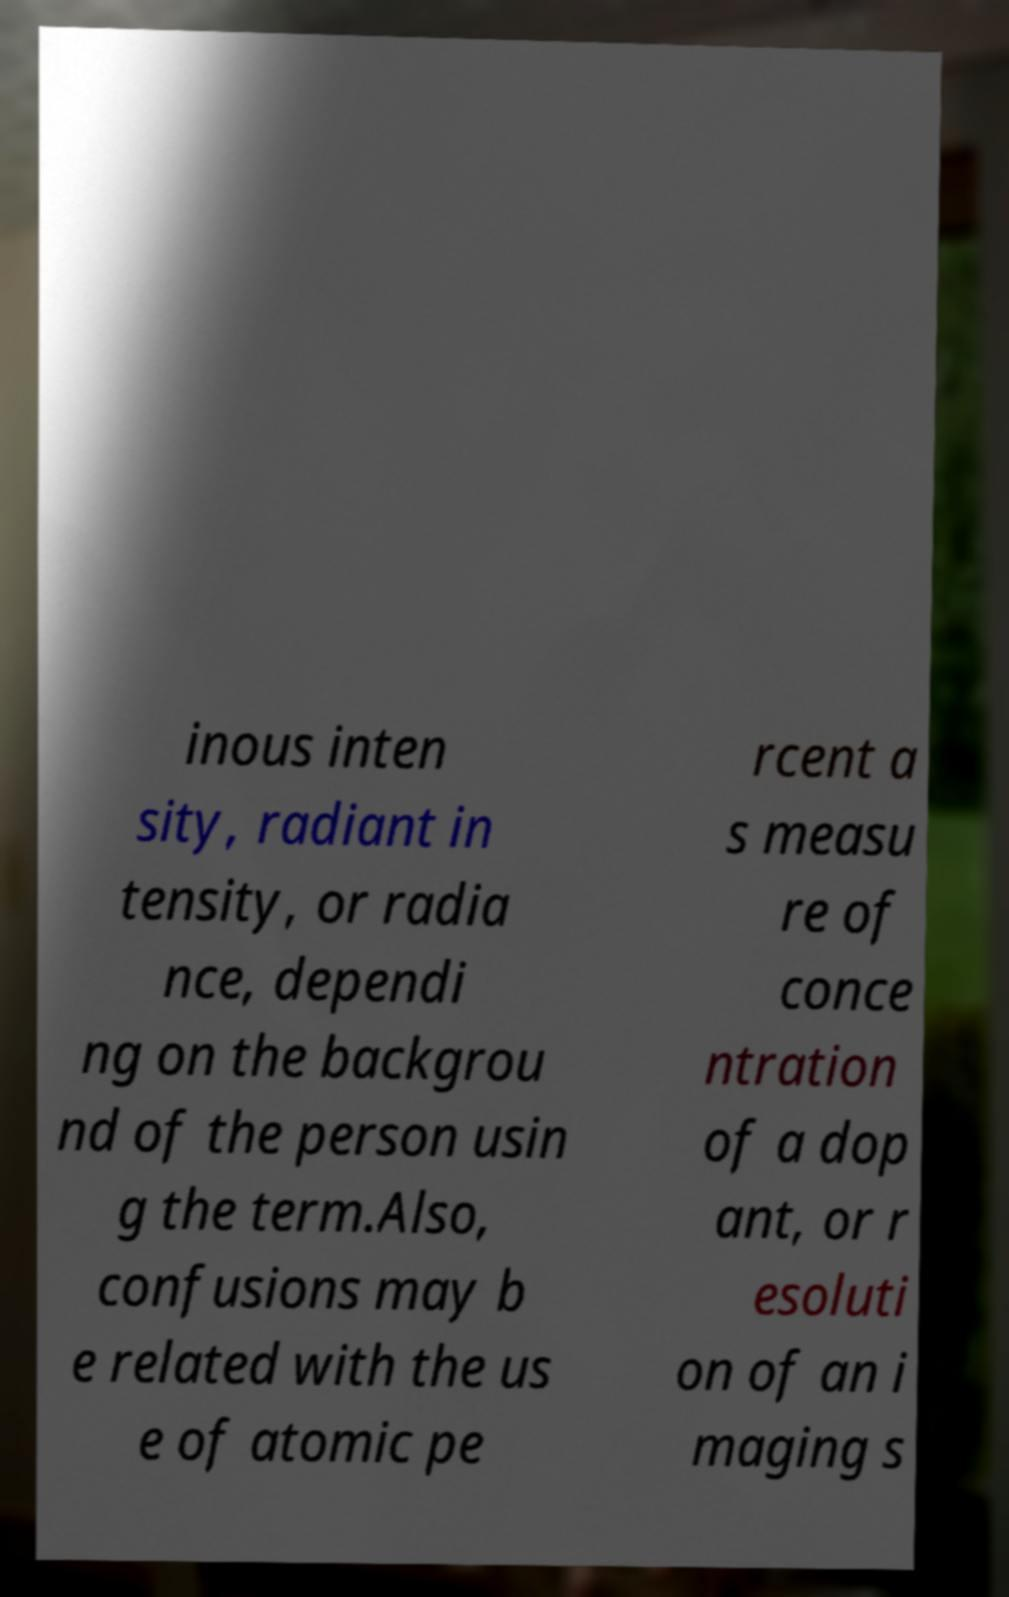Please identify and transcribe the text found in this image. inous inten sity, radiant in tensity, or radia nce, dependi ng on the backgrou nd of the person usin g the term.Also, confusions may b e related with the us e of atomic pe rcent a s measu re of conce ntration of a dop ant, or r esoluti on of an i maging s 